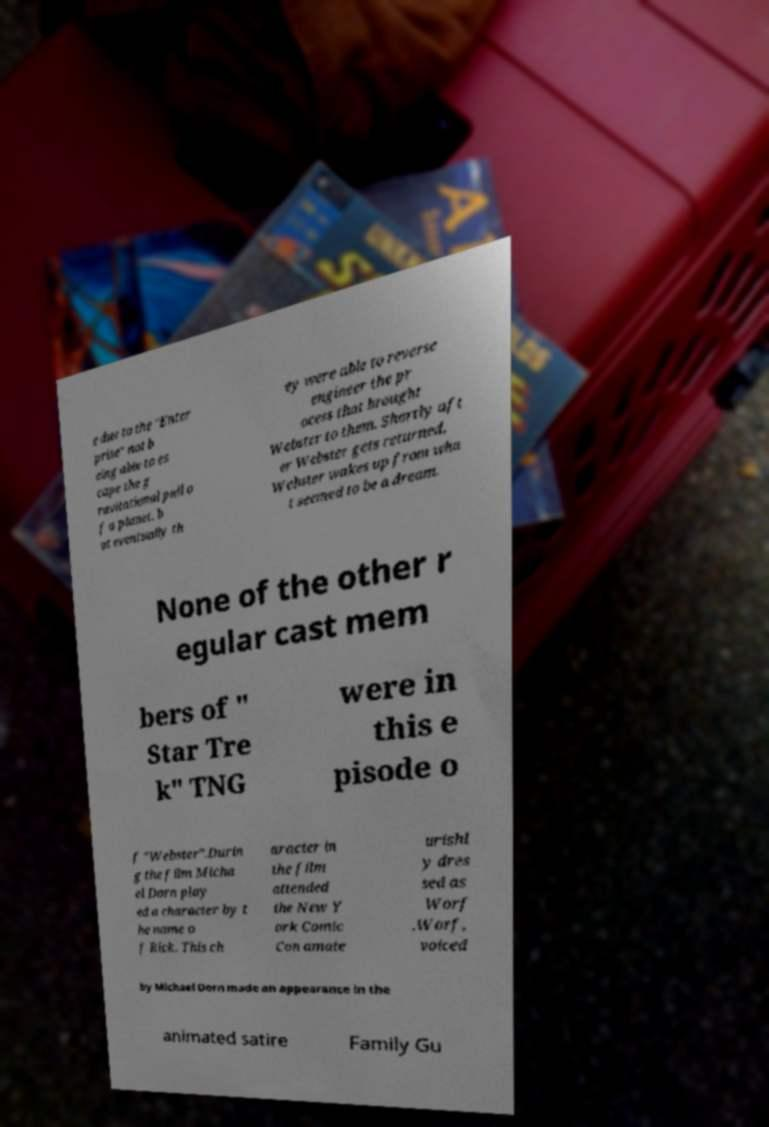Could you extract and type out the text from this image? e due to the "Enter prise" not b eing able to es cape the g ravitational pull o f a planet, b ut eventually th ey were able to reverse engineer the pr ocess that brought Webster to them. Shortly aft er Webster gets returned, Webster wakes up from wha t seemed to be a dream. None of the other r egular cast mem bers of " Star Tre k" TNG were in this e pisode o f "Webster".Durin g the film Micha el Dorn play ed a character by t he name o f Rick. This ch aracter in the film attended the New Y ork Comic Con amate urishl y dres sed as Worf .Worf, voiced by Michael Dorn made an appearance in the animated satire Family Gu 